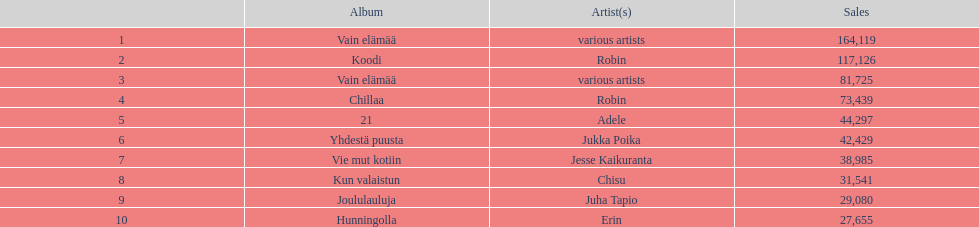Which album precedes 21 in the list? Chillaa. 